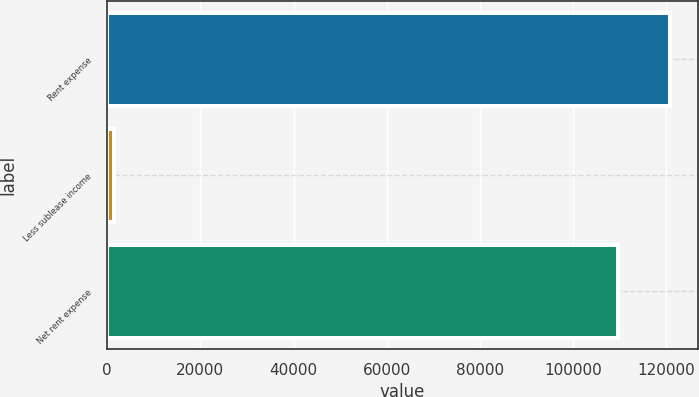<chart> <loc_0><loc_0><loc_500><loc_500><bar_chart><fcel>Rent expense<fcel>Less sublease income<fcel>Net rent expense<nl><fcel>120711<fcel>1412<fcel>109737<nl></chart> 